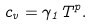Convert formula to latex. <formula><loc_0><loc_0><loc_500><loc_500>c _ { v } = \gamma _ { 1 } T ^ { p } .</formula> 